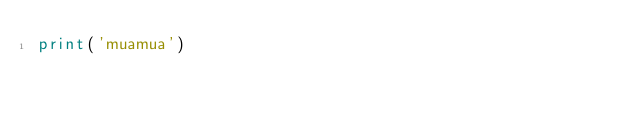Convert code to text. <code><loc_0><loc_0><loc_500><loc_500><_Python_>print('muamua')</code> 